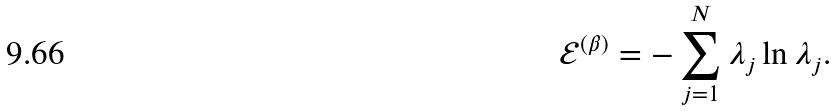Convert formula to latex. <formula><loc_0><loc_0><loc_500><loc_500>\mathcal { E } ^ { ( \beta ) } = - \sum _ { j = 1 } ^ { N } \lambda _ { j } \ln \lambda _ { j } .</formula> 